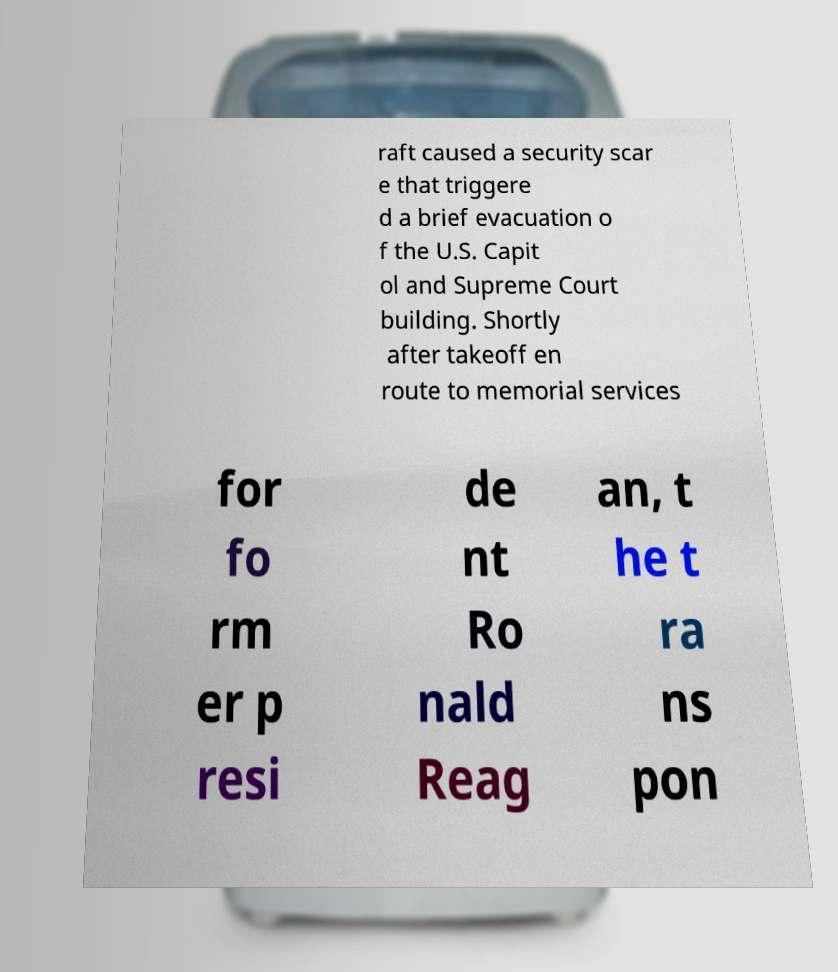I need the written content from this picture converted into text. Can you do that? raft caused a security scar e that triggere d a brief evacuation o f the U.S. Capit ol and Supreme Court building. Shortly after takeoff en route to memorial services for fo rm er p resi de nt Ro nald Reag an, t he t ra ns pon 